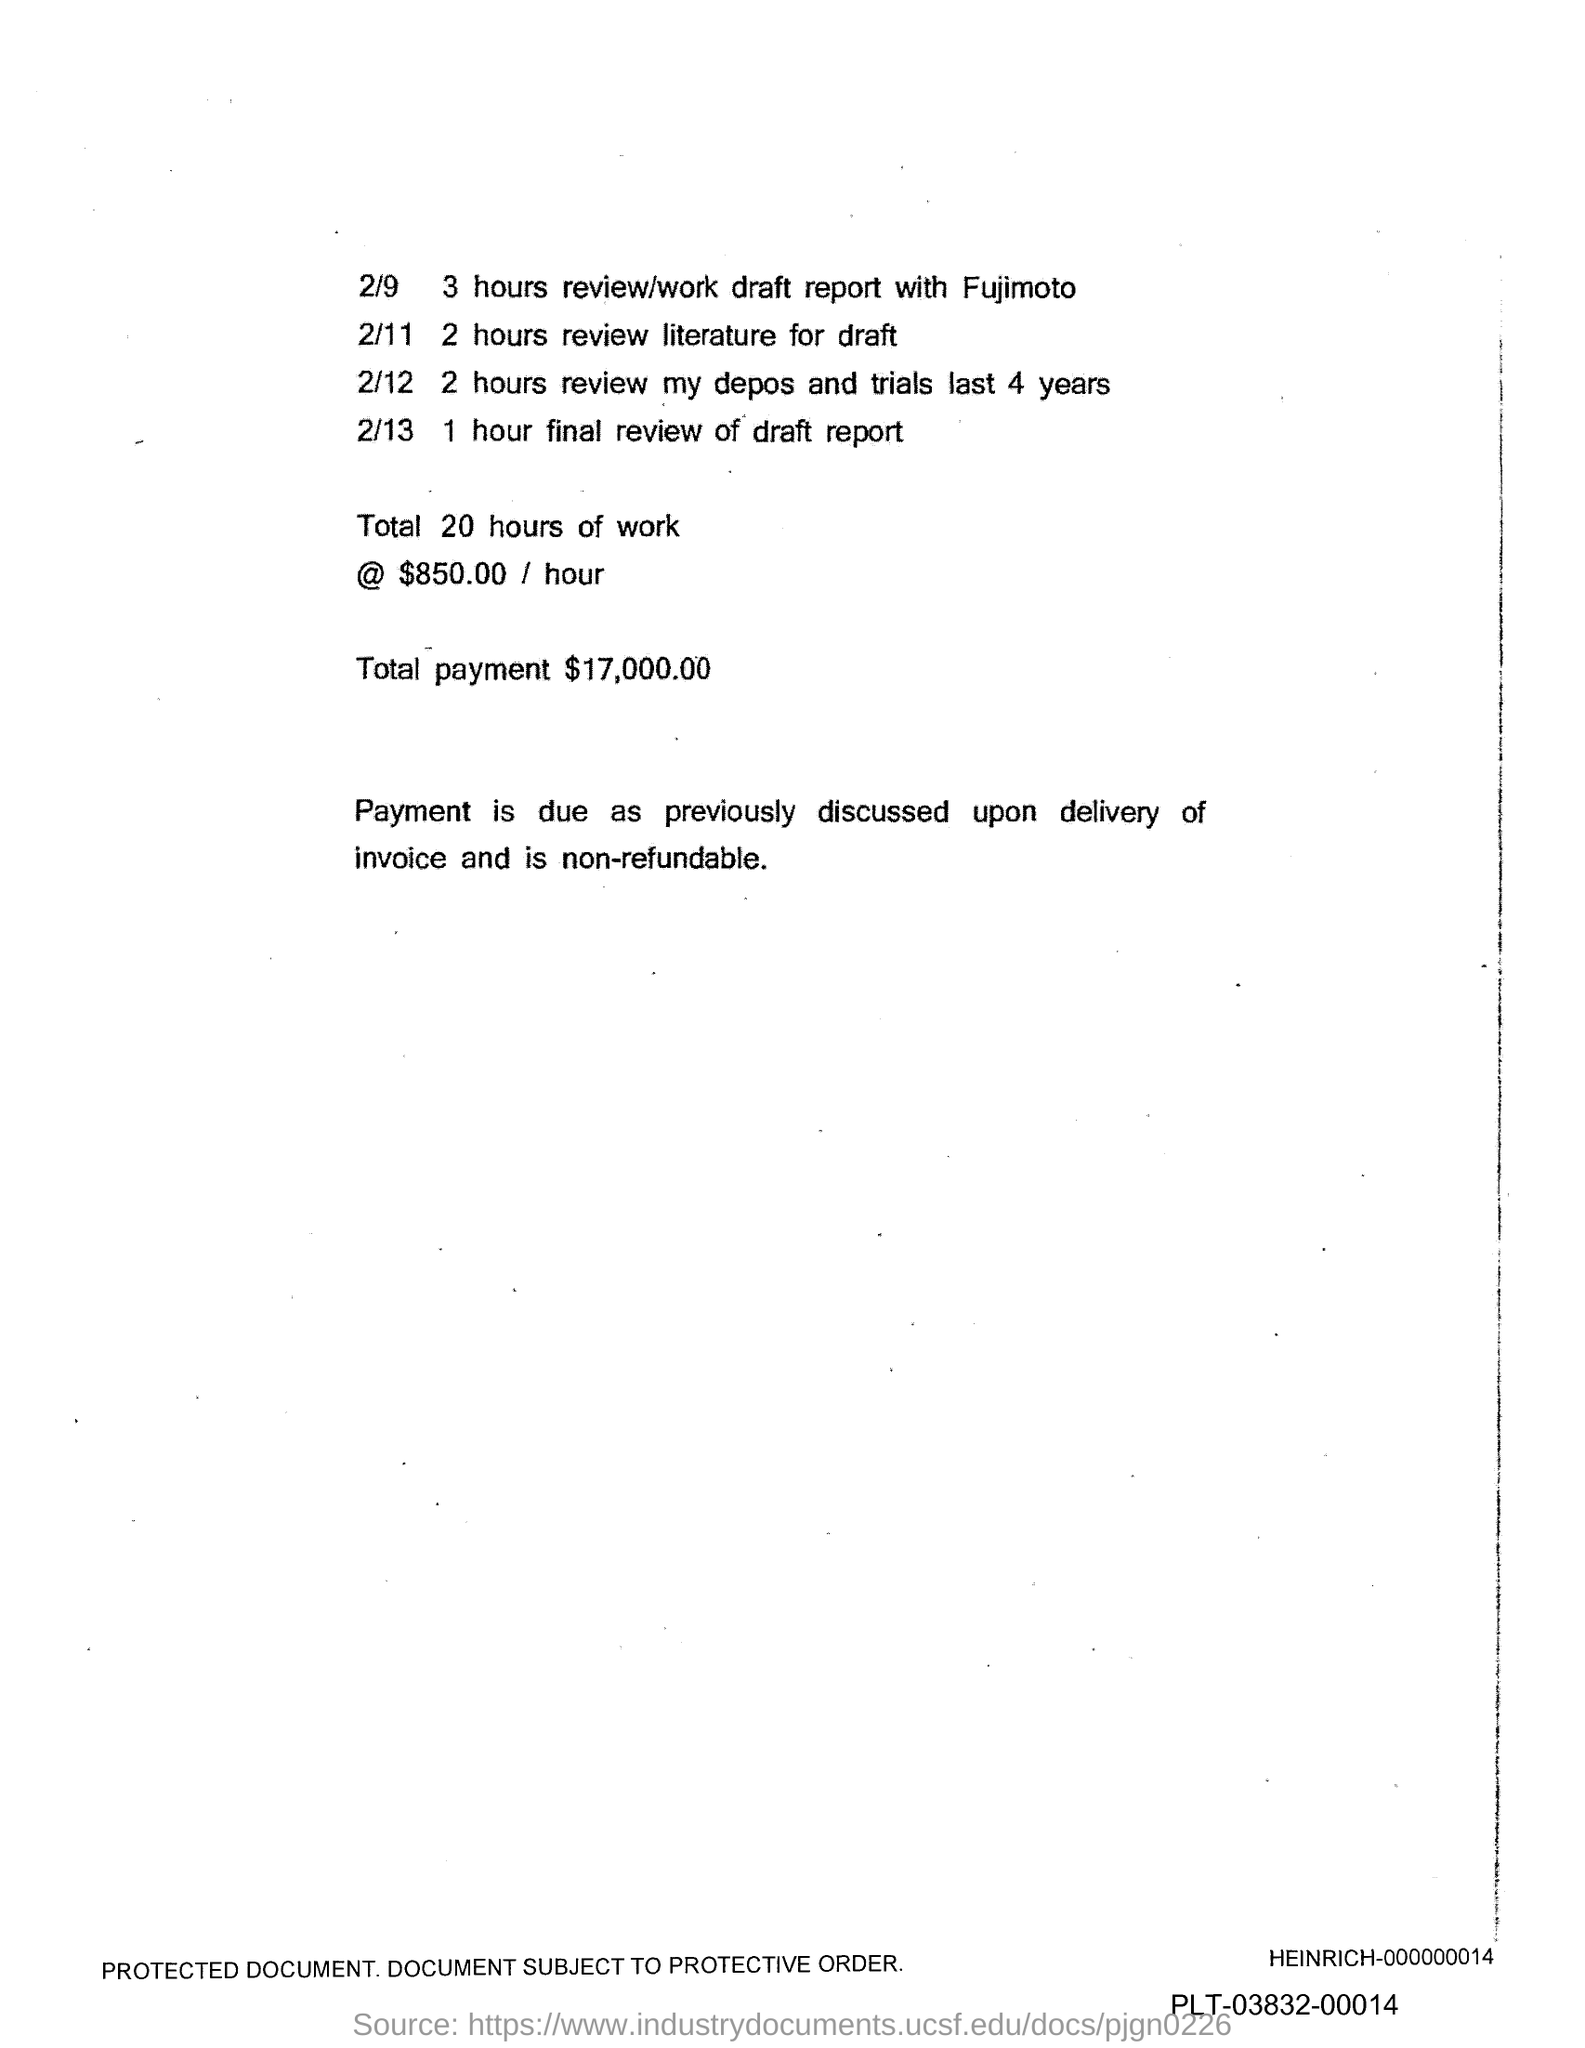Outline some significant characteristics in this image. The total payment is $17,000.00. 